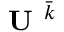<formula> <loc_0><loc_0><loc_500><loc_500>U ^ { \bar { k } }</formula> 